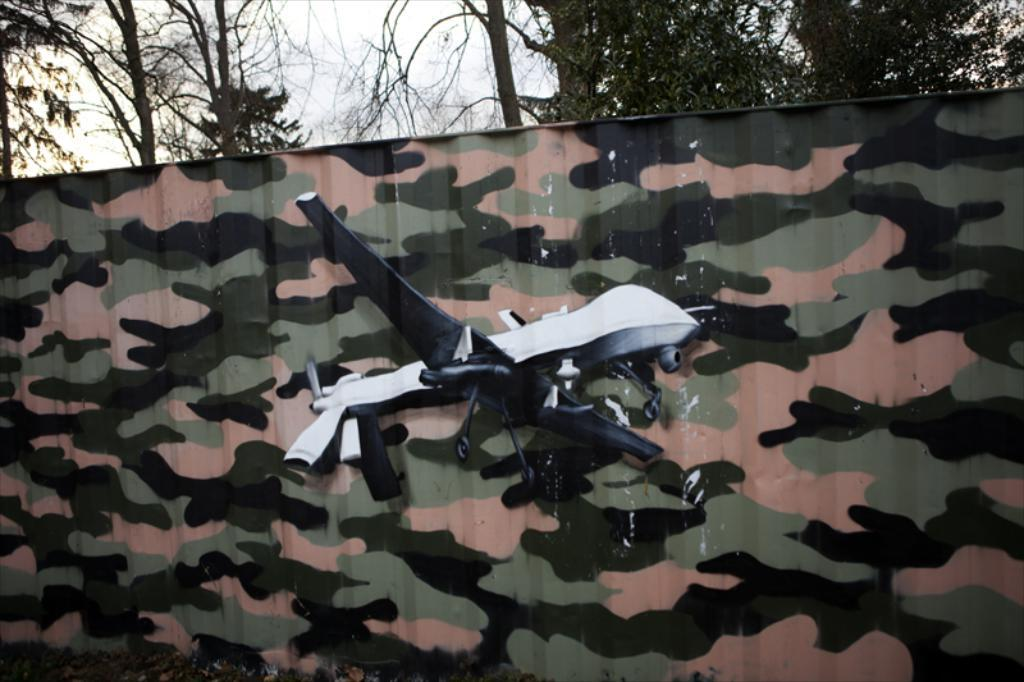What type of toy is in the image? There is a toy in the shape of a plane in the image. What is the toy placed in front of? The toy is in front of a cloth. What can be seen behind the toy and cloth? There are trees visible behind the toy and cloth. What type of worm can be seen crawling on the toy in the image? There is no worm present in the image; it only features a toy in the shape of a plane, a cloth, and trees in the background. 